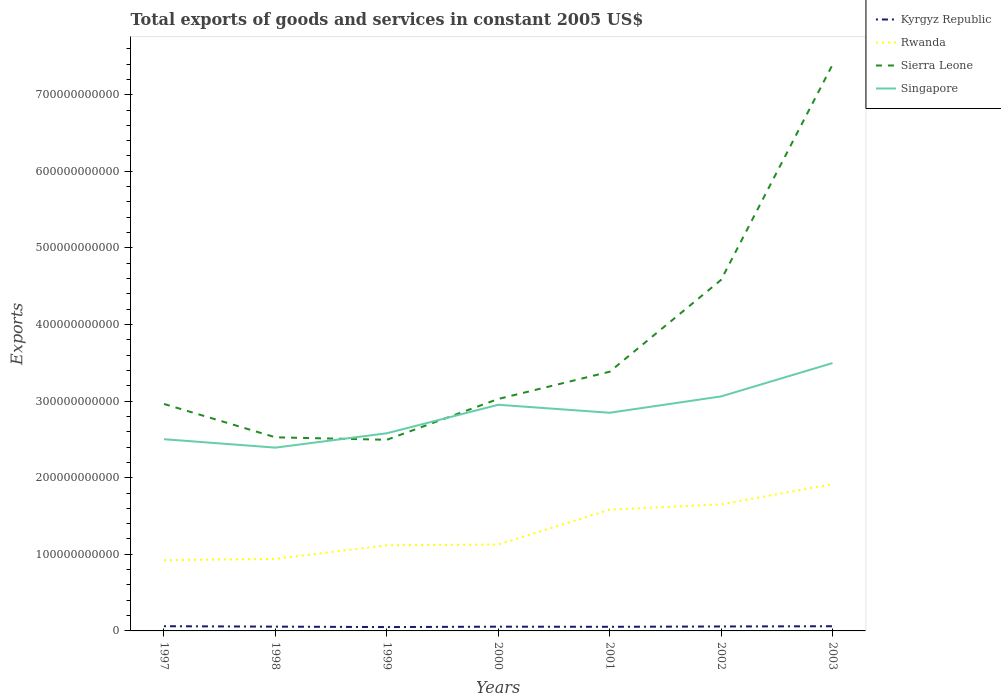How many different coloured lines are there?
Your answer should be very brief. 4. Is the number of lines equal to the number of legend labels?
Provide a short and direct response. Yes. Across all years, what is the maximum total exports of goods and services in Rwanda?
Provide a short and direct response. 9.23e+1. What is the total total exports of goods and services in Sierra Leone in the graph?
Offer a very short reply. -6.50e+09. What is the difference between the highest and the second highest total exports of goods and services in Singapore?
Offer a terse response. 1.10e+11. What is the difference between the highest and the lowest total exports of goods and services in Sierra Leone?
Ensure brevity in your answer.  2. How many years are there in the graph?
Provide a succinct answer. 7. What is the difference between two consecutive major ticks on the Y-axis?
Give a very brief answer. 1.00e+11. Does the graph contain any zero values?
Make the answer very short. No. What is the title of the graph?
Your response must be concise. Total exports of goods and services in constant 2005 US$. What is the label or title of the X-axis?
Make the answer very short. Years. What is the label or title of the Y-axis?
Ensure brevity in your answer.  Exports. What is the Exports in Kyrgyz Republic in 1997?
Keep it short and to the point. 6.14e+09. What is the Exports in Rwanda in 1997?
Provide a short and direct response. 9.23e+1. What is the Exports in Sierra Leone in 1997?
Give a very brief answer. 2.96e+11. What is the Exports of Singapore in 1997?
Your answer should be very brief. 2.50e+11. What is the Exports in Kyrgyz Republic in 1998?
Your response must be concise. 5.61e+09. What is the Exports in Rwanda in 1998?
Keep it short and to the point. 9.41e+1. What is the Exports of Sierra Leone in 1998?
Make the answer very short. 2.53e+11. What is the Exports in Singapore in 1998?
Make the answer very short. 2.39e+11. What is the Exports in Kyrgyz Republic in 1999?
Ensure brevity in your answer.  5.02e+09. What is the Exports in Rwanda in 1999?
Give a very brief answer. 1.12e+11. What is the Exports of Sierra Leone in 1999?
Your response must be concise. 2.50e+11. What is the Exports in Singapore in 1999?
Your answer should be very brief. 2.58e+11. What is the Exports of Kyrgyz Republic in 2000?
Provide a succinct answer. 5.55e+09. What is the Exports in Rwanda in 2000?
Provide a short and direct response. 1.13e+11. What is the Exports in Sierra Leone in 2000?
Provide a short and direct response. 3.03e+11. What is the Exports in Singapore in 2000?
Offer a terse response. 2.95e+11. What is the Exports of Kyrgyz Republic in 2001?
Give a very brief answer. 5.37e+09. What is the Exports of Rwanda in 2001?
Keep it short and to the point. 1.58e+11. What is the Exports in Sierra Leone in 2001?
Make the answer very short. 3.38e+11. What is the Exports of Singapore in 2001?
Provide a succinct answer. 2.85e+11. What is the Exports of Kyrgyz Republic in 2002?
Offer a terse response. 5.81e+09. What is the Exports in Rwanda in 2002?
Keep it short and to the point. 1.65e+11. What is the Exports of Sierra Leone in 2002?
Offer a terse response. 4.58e+11. What is the Exports in Singapore in 2002?
Provide a short and direct response. 3.06e+11. What is the Exports of Kyrgyz Republic in 2003?
Keep it short and to the point. 6.11e+09. What is the Exports in Rwanda in 2003?
Your answer should be compact. 1.92e+11. What is the Exports of Sierra Leone in 2003?
Offer a very short reply. 7.39e+11. What is the Exports of Singapore in 2003?
Give a very brief answer. 3.50e+11. Across all years, what is the maximum Exports of Kyrgyz Republic?
Provide a succinct answer. 6.14e+09. Across all years, what is the maximum Exports of Rwanda?
Provide a succinct answer. 1.92e+11. Across all years, what is the maximum Exports of Sierra Leone?
Ensure brevity in your answer.  7.39e+11. Across all years, what is the maximum Exports of Singapore?
Your answer should be very brief. 3.50e+11. Across all years, what is the minimum Exports in Kyrgyz Republic?
Your response must be concise. 5.02e+09. Across all years, what is the minimum Exports in Rwanda?
Offer a terse response. 9.23e+1. Across all years, what is the minimum Exports of Sierra Leone?
Make the answer very short. 2.50e+11. Across all years, what is the minimum Exports of Singapore?
Ensure brevity in your answer.  2.39e+11. What is the total Exports in Kyrgyz Republic in the graph?
Provide a succinct answer. 3.96e+1. What is the total Exports of Rwanda in the graph?
Ensure brevity in your answer.  9.26e+11. What is the total Exports in Sierra Leone in the graph?
Provide a succinct answer. 2.64e+12. What is the total Exports in Singapore in the graph?
Your answer should be compact. 1.98e+12. What is the difference between the Exports of Kyrgyz Republic in 1997 and that in 1998?
Give a very brief answer. 5.37e+08. What is the difference between the Exports of Rwanda in 1997 and that in 1998?
Ensure brevity in your answer.  -1.75e+09. What is the difference between the Exports in Sierra Leone in 1997 and that in 1998?
Ensure brevity in your answer.  4.36e+1. What is the difference between the Exports of Singapore in 1997 and that in 1998?
Provide a short and direct response. 1.10e+1. What is the difference between the Exports in Kyrgyz Republic in 1997 and that in 1999?
Offer a terse response. 1.12e+09. What is the difference between the Exports of Rwanda in 1997 and that in 1999?
Your answer should be compact. -1.95e+1. What is the difference between the Exports in Sierra Leone in 1997 and that in 1999?
Provide a succinct answer. 4.68e+1. What is the difference between the Exports of Singapore in 1997 and that in 1999?
Make the answer very short. -7.75e+09. What is the difference between the Exports in Kyrgyz Republic in 1997 and that in 2000?
Provide a succinct answer. 5.92e+08. What is the difference between the Exports in Rwanda in 1997 and that in 2000?
Give a very brief answer. -2.05e+1. What is the difference between the Exports in Sierra Leone in 1997 and that in 2000?
Offer a very short reply. -6.50e+09. What is the difference between the Exports in Singapore in 1997 and that in 2000?
Give a very brief answer. -4.50e+1. What is the difference between the Exports in Kyrgyz Republic in 1997 and that in 2001?
Provide a short and direct response. 7.72e+08. What is the difference between the Exports of Rwanda in 1997 and that in 2001?
Your answer should be compact. -6.59e+1. What is the difference between the Exports of Sierra Leone in 1997 and that in 2001?
Your answer should be very brief. -4.21e+1. What is the difference between the Exports in Singapore in 1997 and that in 2001?
Give a very brief answer. -3.45e+1. What is the difference between the Exports of Kyrgyz Republic in 1997 and that in 2002?
Ensure brevity in your answer.  3.38e+08. What is the difference between the Exports in Rwanda in 1997 and that in 2002?
Provide a short and direct response. -7.29e+1. What is the difference between the Exports of Sierra Leone in 1997 and that in 2002?
Your answer should be very brief. -1.62e+11. What is the difference between the Exports of Singapore in 1997 and that in 2002?
Your response must be concise. -5.59e+1. What is the difference between the Exports in Kyrgyz Republic in 1997 and that in 2003?
Your answer should be compact. 3.05e+07. What is the difference between the Exports in Rwanda in 1997 and that in 2003?
Offer a very short reply. -9.93e+1. What is the difference between the Exports in Sierra Leone in 1997 and that in 2003?
Offer a very short reply. -4.43e+11. What is the difference between the Exports in Singapore in 1997 and that in 2003?
Your answer should be very brief. -9.94e+1. What is the difference between the Exports in Kyrgyz Republic in 1998 and that in 1999?
Provide a succinct answer. 5.83e+08. What is the difference between the Exports of Rwanda in 1998 and that in 1999?
Make the answer very short. -1.77e+1. What is the difference between the Exports of Sierra Leone in 1998 and that in 1999?
Provide a succinct answer. 3.23e+09. What is the difference between the Exports in Singapore in 1998 and that in 1999?
Your answer should be compact. -1.87e+1. What is the difference between the Exports in Kyrgyz Republic in 1998 and that in 2000?
Make the answer very short. 5.52e+07. What is the difference between the Exports in Rwanda in 1998 and that in 2000?
Give a very brief answer. -1.87e+1. What is the difference between the Exports of Sierra Leone in 1998 and that in 2000?
Keep it short and to the point. -5.01e+1. What is the difference between the Exports in Singapore in 1998 and that in 2000?
Ensure brevity in your answer.  -5.60e+1. What is the difference between the Exports in Kyrgyz Republic in 1998 and that in 2001?
Make the answer very short. 2.35e+08. What is the difference between the Exports in Rwanda in 1998 and that in 2001?
Offer a very short reply. -6.41e+1. What is the difference between the Exports in Sierra Leone in 1998 and that in 2001?
Keep it short and to the point. -8.56e+1. What is the difference between the Exports of Singapore in 1998 and that in 2001?
Keep it short and to the point. -4.55e+1. What is the difference between the Exports of Kyrgyz Republic in 1998 and that in 2002?
Your answer should be compact. -1.99e+08. What is the difference between the Exports of Rwanda in 1998 and that in 2002?
Ensure brevity in your answer.  -7.12e+1. What is the difference between the Exports of Sierra Leone in 1998 and that in 2002?
Offer a very short reply. -2.06e+11. What is the difference between the Exports in Singapore in 1998 and that in 2002?
Make the answer very short. -6.69e+1. What is the difference between the Exports in Kyrgyz Republic in 1998 and that in 2003?
Your answer should be compact. -5.06e+08. What is the difference between the Exports in Rwanda in 1998 and that in 2003?
Provide a succinct answer. -9.76e+1. What is the difference between the Exports in Sierra Leone in 1998 and that in 2003?
Provide a short and direct response. -4.86e+11. What is the difference between the Exports of Singapore in 1998 and that in 2003?
Provide a succinct answer. -1.10e+11. What is the difference between the Exports in Kyrgyz Republic in 1999 and that in 2000?
Keep it short and to the point. -5.28e+08. What is the difference between the Exports of Rwanda in 1999 and that in 2000?
Ensure brevity in your answer.  -9.73e+08. What is the difference between the Exports in Sierra Leone in 1999 and that in 2000?
Your response must be concise. -5.33e+1. What is the difference between the Exports of Singapore in 1999 and that in 2000?
Make the answer very short. -3.72e+1. What is the difference between the Exports of Kyrgyz Republic in 1999 and that in 2001?
Give a very brief answer. -3.48e+08. What is the difference between the Exports of Rwanda in 1999 and that in 2001?
Your response must be concise. -4.64e+1. What is the difference between the Exports of Sierra Leone in 1999 and that in 2001?
Make the answer very short. -8.89e+1. What is the difference between the Exports in Singapore in 1999 and that in 2001?
Keep it short and to the point. -2.68e+1. What is the difference between the Exports in Kyrgyz Republic in 1999 and that in 2002?
Offer a very short reply. -7.82e+08. What is the difference between the Exports in Rwanda in 1999 and that in 2002?
Provide a succinct answer. -5.34e+1. What is the difference between the Exports of Sierra Leone in 1999 and that in 2002?
Your answer should be very brief. -2.09e+11. What is the difference between the Exports of Singapore in 1999 and that in 2002?
Your answer should be compact. -4.81e+1. What is the difference between the Exports of Kyrgyz Republic in 1999 and that in 2003?
Provide a succinct answer. -1.09e+09. What is the difference between the Exports in Rwanda in 1999 and that in 2003?
Keep it short and to the point. -7.98e+1. What is the difference between the Exports of Sierra Leone in 1999 and that in 2003?
Offer a terse response. -4.90e+11. What is the difference between the Exports of Singapore in 1999 and that in 2003?
Your answer should be compact. -9.16e+1. What is the difference between the Exports of Kyrgyz Republic in 2000 and that in 2001?
Offer a terse response. 1.80e+08. What is the difference between the Exports in Rwanda in 2000 and that in 2001?
Provide a succinct answer. -4.54e+1. What is the difference between the Exports of Sierra Leone in 2000 and that in 2001?
Your answer should be compact. -3.56e+1. What is the difference between the Exports of Singapore in 2000 and that in 2001?
Offer a terse response. 1.04e+1. What is the difference between the Exports of Kyrgyz Republic in 2000 and that in 2002?
Make the answer very short. -2.54e+08. What is the difference between the Exports of Rwanda in 2000 and that in 2002?
Keep it short and to the point. -5.25e+1. What is the difference between the Exports of Sierra Leone in 2000 and that in 2002?
Provide a succinct answer. -1.55e+11. What is the difference between the Exports of Singapore in 2000 and that in 2002?
Your answer should be very brief. -1.09e+1. What is the difference between the Exports in Kyrgyz Republic in 2000 and that in 2003?
Your answer should be very brief. -5.61e+08. What is the difference between the Exports in Rwanda in 2000 and that in 2003?
Ensure brevity in your answer.  -7.88e+1. What is the difference between the Exports in Sierra Leone in 2000 and that in 2003?
Your response must be concise. -4.36e+11. What is the difference between the Exports of Singapore in 2000 and that in 2003?
Offer a very short reply. -5.44e+1. What is the difference between the Exports of Kyrgyz Republic in 2001 and that in 2002?
Your response must be concise. -4.34e+08. What is the difference between the Exports in Rwanda in 2001 and that in 2002?
Provide a succinct answer. -7.03e+09. What is the difference between the Exports in Sierra Leone in 2001 and that in 2002?
Offer a terse response. -1.20e+11. What is the difference between the Exports of Singapore in 2001 and that in 2002?
Give a very brief answer. -2.13e+1. What is the difference between the Exports of Kyrgyz Republic in 2001 and that in 2003?
Ensure brevity in your answer.  -7.41e+08. What is the difference between the Exports in Rwanda in 2001 and that in 2003?
Offer a terse response. -3.34e+1. What is the difference between the Exports of Sierra Leone in 2001 and that in 2003?
Your answer should be very brief. -4.01e+11. What is the difference between the Exports of Singapore in 2001 and that in 2003?
Offer a terse response. -6.49e+1. What is the difference between the Exports of Kyrgyz Republic in 2002 and that in 2003?
Make the answer very short. -3.07e+08. What is the difference between the Exports of Rwanda in 2002 and that in 2003?
Your response must be concise. -2.64e+1. What is the difference between the Exports of Sierra Leone in 2002 and that in 2003?
Offer a terse response. -2.81e+11. What is the difference between the Exports in Singapore in 2002 and that in 2003?
Make the answer very short. -4.35e+1. What is the difference between the Exports of Kyrgyz Republic in 1997 and the Exports of Rwanda in 1998?
Make the answer very short. -8.79e+1. What is the difference between the Exports of Kyrgyz Republic in 1997 and the Exports of Sierra Leone in 1998?
Make the answer very short. -2.47e+11. What is the difference between the Exports of Kyrgyz Republic in 1997 and the Exports of Singapore in 1998?
Your answer should be very brief. -2.33e+11. What is the difference between the Exports in Rwanda in 1997 and the Exports in Sierra Leone in 1998?
Keep it short and to the point. -1.60e+11. What is the difference between the Exports of Rwanda in 1997 and the Exports of Singapore in 1998?
Your answer should be compact. -1.47e+11. What is the difference between the Exports of Sierra Leone in 1997 and the Exports of Singapore in 1998?
Provide a succinct answer. 5.70e+1. What is the difference between the Exports of Kyrgyz Republic in 1997 and the Exports of Rwanda in 1999?
Provide a succinct answer. -1.06e+11. What is the difference between the Exports of Kyrgyz Republic in 1997 and the Exports of Sierra Leone in 1999?
Your response must be concise. -2.43e+11. What is the difference between the Exports of Kyrgyz Republic in 1997 and the Exports of Singapore in 1999?
Your response must be concise. -2.52e+11. What is the difference between the Exports of Rwanda in 1997 and the Exports of Sierra Leone in 1999?
Offer a terse response. -1.57e+11. What is the difference between the Exports of Rwanda in 1997 and the Exports of Singapore in 1999?
Offer a very short reply. -1.66e+11. What is the difference between the Exports in Sierra Leone in 1997 and the Exports in Singapore in 1999?
Provide a short and direct response. 3.83e+1. What is the difference between the Exports in Kyrgyz Republic in 1997 and the Exports in Rwanda in 2000?
Ensure brevity in your answer.  -1.07e+11. What is the difference between the Exports of Kyrgyz Republic in 1997 and the Exports of Sierra Leone in 2000?
Your answer should be very brief. -2.97e+11. What is the difference between the Exports in Kyrgyz Republic in 1997 and the Exports in Singapore in 2000?
Your response must be concise. -2.89e+11. What is the difference between the Exports in Rwanda in 1997 and the Exports in Sierra Leone in 2000?
Give a very brief answer. -2.10e+11. What is the difference between the Exports of Rwanda in 1997 and the Exports of Singapore in 2000?
Offer a very short reply. -2.03e+11. What is the difference between the Exports in Sierra Leone in 1997 and the Exports in Singapore in 2000?
Ensure brevity in your answer.  1.06e+09. What is the difference between the Exports in Kyrgyz Republic in 1997 and the Exports in Rwanda in 2001?
Your answer should be compact. -1.52e+11. What is the difference between the Exports of Kyrgyz Republic in 1997 and the Exports of Sierra Leone in 2001?
Provide a succinct answer. -3.32e+11. What is the difference between the Exports in Kyrgyz Republic in 1997 and the Exports in Singapore in 2001?
Keep it short and to the point. -2.79e+11. What is the difference between the Exports in Rwanda in 1997 and the Exports in Sierra Leone in 2001?
Give a very brief answer. -2.46e+11. What is the difference between the Exports of Rwanda in 1997 and the Exports of Singapore in 2001?
Keep it short and to the point. -1.92e+11. What is the difference between the Exports in Sierra Leone in 1997 and the Exports in Singapore in 2001?
Provide a short and direct response. 1.15e+1. What is the difference between the Exports in Kyrgyz Republic in 1997 and the Exports in Rwanda in 2002?
Keep it short and to the point. -1.59e+11. What is the difference between the Exports in Kyrgyz Republic in 1997 and the Exports in Sierra Leone in 2002?
Give a very brief answer. -4.52e+11. What is the difference between the Exports in Kyrgyz Republic in 1997 and the Exports in Singapore in 2002?
Offer a very short reply. -3.00e+11. What is the difference between the Exports in Rwanda in 1997 and the Exports in Sierra Leone in 2002?
Keep it short and to the point. -3.66e+11. What is the difference between the Exports in Rwanda in 1997 and the Exports in Singapore in 2002?
Make the answer very short. -2.14e+11. What is the difference between the Exports in Sierra Leone in 1997 and the Exports in Singapore in 2002?
Give a very brief answer. -9.84e+09. What is the difference between the Exports in Kyrgyz Republic in 1997 and the Exports in Rwanda in 2003?
Provide a succinct answer. -1.85e+11. What is the difference between the Exports of Kyrgyz Republic in 1997 and the Exports of Sierra Leone in 2003?
Provide a succinct answer. -7.33e+11. What is the difference between the Exports of Kyrgyz Republic in 1997 and the Exports of Singapore in 2003?
Ensure brevity in your answer.  -3.44e+11. What is the difference between the Exports in Rwanda in 1997 and the Exports in Sierra Leone in 2003?
Your response must be concise. -6.47e+11. What is the difference between the Exports of Rwanda in 1997 and the Exports of Singapore in 2003?
Ensure brevity in your answer.  -2.57e+11. What is the difference between the Exports in Sierra Leone in 1997 and the Exports in Singapore in 2003?
Give a very brief answer. -5.33e+1. What is the difference between the Exports of Kyrgyz Republic in 1998 and the Exports of Rwanda in 1999?
Your answer should be very brief. -1.06e+11. What is the difference between the Exports in Kyrgyz Republic in 1998 and the Exports in Sierra Leone in 1999?
Your response must be concise. -2.44e+11. What is the difference between the Exports in Kyrgyz Republic in 1998 and the Exports in Singapore in 1999?
Provide a succinct answer. -2.52e+11. What is the difference between the Exports in Rwanda in 1998 and the Exports in Sierra Leone in 1999?
Make the answer very short. -1.55e+11. What is the difference between the Exports of Rwanda in 1998 and the Exports of Singapore in 1999?
Offer a very short reply. -1.64e+11. What is the difference between the Exports in Sierra Leone in 1998 and the Exports in Singapore in 1999?
Your answer should be compact. -5.26e+09. What is the difference between the Exports of Kyrgyz Republic in 1998 and the Exports of Rwanda in 2000?
Give a very brief answer. -1.07e+11. What is the difference between the Exports of Kyrgyz Republic in 1998 and the Exports of Sierra Leone in 2000?
Make the answer very short. -2.97e+11. What is the difference between the Exports of Kyrgyz Republic in 1998 and the Exports of Singapore in 2000?
Offer a very short reply. -2.90e+11. What is the difference between the Exports in Rwanda in 1998 and the Exports in Sierra Leone in 2000?
Your response must be concise. -2.09e+11. What is the difference between the Exports of Rwanda in 1998 and the Exports of Singapore in 2000?
Provide a short and direct response. -2.01e+11. What is the difference between the Exports in Sierra Leone in 1998 and the Exports in Singapore in 2000?
Keep it short and to the point. -4.25e+1. What is the difference between the Exports of Kyrgyz Republic in 1998 and the Exports of Rwanda in 2001?
Provide a short and direct response. -1.53e+11. What is the difference between the Exports in Kyrgyz Republic in 1998 and the Exports in Sierra Leone in 2001?
Your response must be concise. -3.33e+11. What is the difference between the Exports of Kyrgyz Republic in 1998 and the Exports of Singapore in 2001?
Give a very brief answer. -2.79e+11. What is the difference between the Exports of Rwanda in 1998 and the Exports of Sierra Leone in 2001?
Your response must be concise. -2.44e+11. What is the difference between the Exports in Rwanda in 1998 and the Exports in Singapore in 2001?
Offer a terse response. -1.91e+11. What is the difference between the Exports in Sierra Leone in 1998 and the Exports in Singapore in 2001?
Offer a very short reply. -3.20e+1. What is the difference between the Exports of Kyrgyz Republic in 1998 and the Exports of Rwanda in 2002?
Your answer should be very brief. -1.60e+11. What is the difference between the Exports in Kyrgyz Republic in 1998 and the Exports in Sierra Leone in 2002?
Keep it short and to the point. -4.53e+11. What is the difference between the Exports in Kyrgyz Republic in 1998 and the Exports in Singapore in 2002?
Your answer should be compact. -3.01e+11. What is the difference between the Exports of Rwanda in 1998 and the Exports of Sierra Leone in 2002?
Make the answer very short. -3.64e+11. What is the difference between the Exports in Rwanda in 1998 and the Exports in Singapore in 2002?
Provide a short and direct response. -2.12e+11. What is the difference between the Exports in Sierra Leone in 1998 and the Exports in Singapore in 2002?
Offer a terse response. -5.34e+1. What is the difference between the Exports of Kyrgyz Republic in 1998 and the Exports of Rwanda in 2003?
Your answer should be compact. -1.86e+11. What is the difference between the Exports in Kyrgyz Republic in 1998 and the Exports in Sierra Leone in 2003?
Your answer should be very brief. -7.34e+11. What is the difference between the Exports of Kyrgyz Republic in 1998 and the Exports of Singapore in 2003?
Offer a very short reply. -3.44e+11. What is the difference between the Exports in Rwanda in 1998 and the Exports in Sierra Leone in 2003?
Keep it short and to the point. -6.45e+11. What is the difference between the Exports in Rwanda in 1998 and the Exports in Singapore in 2003?
Provide a succinct answer. -2.56e+11. What is the difference between the Exports of Sierra Leone in 1998 and the Exports of Singapore in 2003?
Offer a very short reply. -9.69e+1. What is the difference between the Exports in Kyrgyz Republic in 1999 and the Exports in Rwanda in 2000?
Offer a terse response. -1.08e+11. What is the difference between the Exports in Kyrgyz Republic in 1999 and the Exports in Sierra Leone in 2000?
Offer a very short reply. -2.98e+11. What is the difference between the Exports of Kyrgyz Republic in 1999 and the Exports of Singapore in 2000?
Your answer should be very brief. -2.90e+11. What is the difference between the Exports of Rwanda in 1999 and the Exports of Sierra Leone in 2000?
Offer a terse response. -1.91e+11. What is the difference between the Exports of Rwanda in 1999 and the Exports of Singapore in 2000?
Provide a succinct answer. -1.83e+11. What is the difference between the Exports of Sierra Leone in 1999 and the Exports of Singapore in 2000?
Your answer should be compact. -4.57e+1. What is the difference between the Exports in Kyrgyz Republic in 1999 and the Exports in Rwanda in 2001?
Your answer should be compact. -1.53e+11. What is the difference between the Exports of Kyrgyz Republic in 1999 and the Exports of Sierra Leone in 2001?
Ensure brevity in your answer.  -3.33e+11. What is the difference between the Exports in Kyrgyz Republic in 1999 and the Exports in Singapore in 2001?
Your answer should be very brief. -2.80e+11. What is the difference between the Exports of Rwanda in 1999 and the Exports of Sierra Leone in 2001?
Offer a terse response. -2.27e+11. What is the difference between the Exports of Rwanda in 1999 and the Exports of Singapore in 2001?
Provide a short and direct response. -1.73e+11. What is the difference between the Exports of Sierra Leone in 1999 and the Exports of Singapore in 2001?
Your response must be concise. -3.53e+1. What is the difference between the Exports of Kyrgyz Republic in 1999 and the Exports of Rwanda in 2002?
Provide a short and direct response. -1.60e+11. What is the difference between the Exports of Kyrgyz Republic in 1999 and the Exports of Sierra Leone in 2002?
Your answer should be compact. -4.53e+11. What is the difference between the Exports of Kyrgyz Republic in 1999 and the Exports of Singapore in 2002?
Give a very brief answer. -3.01e+11. What is the difference between the Exports in Rwanda in 1999 and the Exports in Sierra Leone in 2002?
Offer a terse response. -3.46e+11. What is the difference between the Exports of Rwanda in 1999 and the Exports of Singapore in 2002?
Make the answer very short. -1.94e+11. What is the difference between the Exports in Sierra Leone in 1999 and the Exports in Singapore in 2002?
Ensure brevity in your answer.  -5.66e+1. What is the difference between the Exports of Kyrgyz Republic in 1999 and the Exports of Rwanda in 2003?
Your response must be concise. -1.87e+11. What is the difference between the Exports in Kyrgyz Republic in 1999 and the Exports in Sierra Leone in 2003?
Your answer should be compact. -7.34e+11. What is the difference between the Exports of Kyrgyz Republic in 1999 and the Exports of Singapore in 2003?
Give a very brief answer. -3.45e+11. What is the difference between the Exports in Rwanda in 1999 and the Exports in Sierra Leone in 2003?
Give a very brief answer. -6.27e+11. What is the difference between the Exports in Rwanda in 1999 and the Exports in Singapore in 2003?
Your answer should be compact. -2.38e+11. What is the difference between the Exports of Sierra Leone in 1999 and the Exports of Singapore in 2003?
Provide a short and direct response. -1.00e+11. What is the difference between the Exports in Kyrgyz Republic in 2000 and the Exports in Rwanda in 2001?
Your answer should be compact. -1.53e+11. What is the difference between the Exports in Kyrgyz Republic in 2000 and the Exports in Sierra Leone in 2001?
Your answer should be very brief. -3.33e+11. What is the difference between the Exports of Kyrgyz Republic in 2000 and the Exports of Singapore in 2001?
Your answer should be compact. -2.79e+11. What is the difference between the Exports in Rwanda in 2000 and the Exports in Sierra Leone in 2001?
Your response must be concise. -2.26e+11. What is the difference between the Exports of Rwanda in 2000 and the Exports of Singapore in 2001?
Your answer should be compact. -1.72e+11. What is the difference between the Exports of Sierra Leone in 2000 and the Exports of Singapore in 2001?
Provide a succinct answer. 1.80e+1. What is the difference between the Exports of Kyrgyz Republic in 2000 and the Exports of Rwanda in 2002?
Your response must be concise. -1.60e+11. What is the difference between the Exports in Kyrgyz Republic in 2000 and the Exports in Sierra Leone in 2002?
Give a very brief answer. -4.53e+11. What is the difference between the Exports in Kyrgyz Republic in 2000 and the Exports in Singapore in 2002?
Make the answer very short. -3.01e+11. What is the difference between the Exports of Rwanda in 2000 and the Exports of Sierra Leone in 2002?
Provide a short and direct response. -3.46e+11. What is the difference between the Exports in Rwanda in 2000 and the Exports in Singapore in 2002?
Keep it short and to the point. -1.93e+11. What is the difference between the Exports of Sierra Leone in 2000 and the Exports of Singapore in 2002?
Keep it short and to the point. -3.34e+09. What is the difference between the Exports in Kyrgyz Republic in 2000 and the Exports in Rwanda in 2003?
Provide a short and direct response. -1.86e+11. What is the difference between the Exports in Kyrgyz Republic in 2000 and the Exports in Sierra Leone in 2003?
Your response must be concise. -7.34e+11. What is the difference between the Exports of Kyrgyz Republic in 2000 and the Exports of Singapore in 2003?
Your answer should be compact. -3.44e+11. What is the difference between the Exports in Rwanda in 2000 and the Exports in Sierra Leone in 2003?
Your answer should be compact. -6.26e+11. What is the difference between the Exports of Rwanda in 2000 and the Exports of Singapore in 2003?
Provide a short and direct response. -2.37e+11. What is the difference between the Exports of Sierra Leone in 2000 and the Exports of Singapore in 2003?
Give a very brief answer. -4.68e+1. What is the difference between the Exports in Kyrgyz Republic in 2001 and the Exports in Rwanda in 2002?
Your answer should be compact. -1.60e+11. What is the difference between the Exports in Kyrgyz Republic in 2001 and the Exports in Sierra Leone in 2002?
Your answer should be compact. -4.53e+11. What is the difference between the Exports in Kyrgyz Republic in 2001 and the Exports in Singapore in 2002?
Ensure brevity in your answer.  -3.01e+11. What is the difference between the Exports in Rwanda in 2001 and the Exports in Sierra Leone in 2002?
Your response must be concise. -3.00e+11. What is the difference between the Exports in Rwanda in 2001 and the Exports in Singapore in 2002?
Your answer should be very brief. -1.48e+11. What is the difference between the Exports of Sierra Leone in 2001 and the Exports of Singapore in 2002?
Provide a succinct answer. 3.22e+1. What is the difference between the Exports of Kyrgyz Republic in 2001 and the Exports of Rwanda in 2003?
Your answer should be compact. -1.86e+11. What is the difference between the Exports in Kyrgyz Republic in 2001 and the Exports in Sierra Leone in 2003?
Keep it short and to the point. -7.34e+11. What is the difference between the Exports in Kyrgyz Republic in 2001 and the Exports in Singapore in 2003?
Your answer should be very brief. -3.44e+11. What is the difference between the Exports in Rwanda in 2001 and the Exports in Sierra Leone in 2003?
Provide a succinct answer. -5.81e+11. What is the difference between the Exports of Rwanda in 2001 and the Exports of Singapore in 2003?
Keep it short and to the point. -1.91e+11. What is the difference between the Exports in Sierra Leone in 2001 and the Exports in Singapore in 2003?
Your answer should be very brief. -1.13e+1. What is the difference between the Exports in Kyrgyz Republic in 2002 and the Exports in Rwanda in 2003?
Offer a terse response. -1.86e+11. What is the difference between the Exports of Kyrgyz Republic in 2002 and the Exports of Sierra Leone in 2003?
Give a very brief answer. -7.33e+11. What is the difference between the Exports of Kyrgyz Republic in 2002 and the Exports of Singapore in 2003?
Provide a short and direct response. -3.44e+11. What is the difference between the Exports of Rwanda in 2002 and the Exports of Sierra Leone in 2003?
Offer a terse response. -5.74e+11. What is the difference between the Exports in Rwanda in 2002 and the Exports in Singapore in 2003?
Provide a succinct answer. -1.84e+11. What is the difference between the Exports of Sierra Leone in 2002 and the Exports of Singapore in 2003?
Make the answer very short. 1.09e+11. What is the average Exports of Kyrgyz Republic per year?
Offer a terse response. 5.66e+09. What is the average Exports in Rwanda per year?
Ensure brevity in your answer.  1.32e+11. What is the average Exports of Sierra Leone per year?
Make the answer very short. 3.77e+11. What is the average Exports in Singapore per year?
Your answer should be compact. 2.83e+11. In the year 1997, what is the difference between the Exports in Kyrgyz Republic and Exports in Rwanda?
Your answer should be very brief. -8.62e+1. In the year 1997, what is the difference between the Exports in Kyrgyz Republic and Exports in Sierra Leone?
Make the answer very short. -2.90e+11. In the year 1997, what is the difference between the Exports in Kyrgyz Republic and Exports in Singapore?
Provide a succinct answer. -2.44e+11. In the year 1997, what is the difference between the Exports of Rwanda and Exports of Sierra Leone?
Your response must be concise. -2.04e+11. In the year 1997, what is the difference between the Exports in Rwanda and Exports in Singapore?
Keep it short and to the point. -1.58e+11. In the year 1997, what is the difference between the Exports in Sierra Leone and Exports in Singapore?
Your answer should be very brief. 4.60e+1. In the year 1998, what is the difference between the Exports in Kyrgyz Republic and Exports in Rwanda?
Give a very brief answer. -8.85e+1. In the year 1998, what is the difference between the Exports of Kyrgyz Republic and Exports of Sierra Leone?
Make the answer very short. -2.47e+11. In the year 1998, what is the difference between the Exports of Kyrgyz Republic and Exports of Singapore?
Ensure brevity in your answer.  -2.34e+11. In the year 1998, what is the difference between the Exports in Rwanda and Exports in Sierra Leone?
Offer a terse response. -1.59e+11. In the year 1998, what is the difference between the Exports of Rwanda and Exports of Singapore?
Make the answer very short. -1.45e+11. In the year 1998, what is the difference between the Exports in Sierra Leone and Exports in Singapore?
Offer a very short reply. 1.35e+1. In the year 1999, what is the difference between the Exports of Kyrgyz Republic and Exports of Rwanda?
Your answer should be compact. -1.07e+11. In the year 1999, what is the difference between the Exports in Kyrgyz Republic and Exports in Sierra Leone?
Your answer should be compact. -2.44e+11. In the year 1999, what is the difference between the Exports in Kyrgyz Republic and Exports in Singapore?
Provide a short and direct response. -2.53e+11. In the year 1999, what is the difference between the Exports in Rwanda and Exports in Sierra Leone?
Give a very brief answer. -1.38e+11. In the year 1999, what is the difference between the Exports of Rwanda and Exports of Singapore?
Provide a short and direct response. -1.46e+11. In the year 1999, what is the difference between the Exports of Sierra Leone and Exports of Singapore?
Keep it short and to the point. -8.49e+09. In the year 2000, what is the difference between the Exports of Kyrgyz Republic and Exports of Rwanda?
Your response must be concise. -1.07e+11. In the year 2000, what is the difference between the Exports in Kyrgyz Republic and Exports in Sierra Leone?
Give a very brief answer. -2.97e+11. In the year 2000, what is the difference between the Exports of Kyrgyz Republic and Exports of Singapore?
Offer a terse response. -2.90e+11. In the year 2000, what is the difference between the Exports of Rwanda and Exports of Sierra Leone?
Your answer should be compact. -1.90e+11. In the year 2000, what is the difference between the Exports of Rwanda and Exports of Singapore?
Your response must be concise. -1.82e+11. In the year 2000, what is the difference between the Exports of Sierra Leone and Exports of Singapore?
Offer a terse response. 7.56e+09. In the year 2001, what is the difference between the Exports of Kyrgyz Republic and Exports of Rwanda?
Your answer should be compact. -1.53e+11. In the year 2001, what is the difference between the Exports in Kyrgyz Republic and Exports in Sierra Leone?
Offer a terse response. -3.33e+11. In the year 2001, what is the difference between the Exports of Kyrgyz Republic and Exports of Singapore?
Your response must be concise. -2.79e+11. In the year 2001, what is the difference between the Exports of Rwanda and Exports of Sierra Leone?
Your answer should be very brief. -1.80e+11. In the year 2001, what is the difference between the Exports of Rwanda and Exports of Singapore?
Your answer should be compact. -1.27e+11. In the year 2001, what is the difference between the Exports of Sierra Leone and Exports of Singapore?
Offer a very short reply. 5.36e+1. In the year 2002, what is the difference between the Exports in Kyrgyz Republic and Exports in Rwanda?
Provide a short and direct response. -1.59e+11. In the year 2002, what is the difference between the Exports of Kyrgyz Republic and Exports of Sierra Leone?
Ensure brevity in your answer.  -4.52e+11. In the year 2002, what is the difference between the Exports of Kyrgyz Republic and Exports of Singapore?
Offer a terse response. -3.00e+11. In the year 2002, what is the difference between the Exports in Rwanda and Exports in Sierra Leone?
Provide a short and direct response. -2.93e+11. In the year 2002, what is the difference between the Exports in Rwanda and Exports in Singapore?
Offer a terse response. -1.41e+11. In the year 2002, what is the difference between the Exports of Sierra Leone and Exports of Singapore?
Keep it short and to the point. 1.52e+11. In the year 2003, what is the difference between the Exports in Kyrgyz Republic and Exports in Rwanda?
Offer a terse response. -1.86e+11. In the year 2003, what is the difference between the Exports in Kyrgyz Republic and Exports in Sierra Leone?
Offer a very short reply. -7.33e+11. In the year 2003, what is the difference between the Exports in Kyrgyz Republic and Exports in Singapore?
Make the answer very short. -3.44e+11. In the year 2003, what is the difference between the Exports in Rwanda and Exports in Sierra Leone?
Your answer should be compact. -5.48e+11. In the year 2003, what is the difference between the Exports of Rwanda and Exports of Singapore?
Your response must be concise. -1.58e+11. In the year 2003, what is the difference between the Exports of Sierra Leone and Exports of Singapore?
Keep it short and to the point. 3.90e+11. What is the ratio of the Exports in Kyrgyz Republic in 1997 to that in 1998?
Offer a very short reply. 1.1. What is the ratio of the Exports of Rwanda in 1997 to that in 1998?
Offer a terse response. 0.98. What is the ratio of the Exports in Sierra Leone in 1997 to that in 1998?
Offer a terse response. 1.17. What is the ratio of the Exports of Singapore in 1997 to that in 1998?
Ensure brevity in your answer.  1.05. What is the ratio of the Exports in Kyrgyz Republic in 1997 to that in 1999?
Offer a very short reply. 1.22. What is the ratio of the Exports in Rwanda in 1997 to that in 1999?
Your answer should be very brief. 0.83. What is the ratio of the Exports in Sierra Leone in 1997 to that in 1999?
Give a very brief answer. 1.19. What is the ratio of the Exports in Kyrgyz Republic in 1997 to that in 2000?
Offer a terse response. 1.11. What is the ratio of the Exports of Rwanda in 1997 to that in 2000?
Offer a terse response. 0.82. What is the ratio of the Exports in Sierra Leone in 1997 to that in 2000?
Provide a short and direct response. 0.98. What is the ratio of the Exports in Singapore in 1997 to that in 2000?
Give a very brief answer. 0.85. What is the ratio of the Exports of Kyrgyz Republic in 1997 to that in 2001?
Offer a terse response. 1.14. What is the ratio of the Exports of Rwanda in 1997 to that in 2001?
Your answer should be compact. 0.58. What is the ratio of the Exports of Sierra Leone in 1997 to that in 2001?
Keep it short and to the point. 0.88. What is the ratio of the Exports in Singapore in 1997 to that in 2001?
Give a very brief answer. 0.88. What is the ratio of the Exports in Kyrgyz Republic in 1997 to that in 2002?
Make the answer very short. 1.06. What is the ratio of the Exports of Rwanda in 1997 to that in 2002?
Provide a succinct answer. 0.56. What is the ratio of the Exports of Sierra Leone in 1997 to that in 2002?
Keep it short and to the point. 0.65. What is the ratio of the Exports in Singapore in 1997 to that in 2002?
Your response must be concise. 0.82. What is the ratio of the Exports in Rwanda in 1997 to that in 2003?
Your answer should be very brief. 0.48. What is the ratio of the Exports of Sierra Leone in 1997 to that in 2003?
Ensure brevity in your answer.  0.4. What is the ratio of the Exports of Singapore in 1997 to that in 2003?
Your answer should be compact. 0.72. What is the ratio of the Exports of Kyrgyz Republic in 1998 to that in 1999?
Ensure brevity in your answer.  1.12. What is the ratio of the Exports in Rwanda in 1998 to that in 1999?
Ensure brevity in your answer.  0.84. What is the ratio of the Exports of Singapore in 1998 to that in 1999?
Provide a succinct answer. 0.93. What is the ratio of the Exports in Kyrgyz Republic in 1998 to that in 2000?
Keep it short and to the point. 1.01. What is the ratio of the Exports of Rwanda in 1998 to that in 2000?
Provide a short and direct response. 0.83. What is the ratio of the Exports of Sierra Leone in 1998 to that in 2000?
Ensure brevity in your answer.  0.83. What is the ratio of the Exports in Singapore in 1998 to that in 2000?
Give a very brief answer. 0.81. What is the ratio of the Exports in Kyrgyz Republic in 1998 to that in 2001?
Your answer should be compact. 1.04. What is the ratio of the Exports of Rwanda in 1998 to that in 2001?
Offer a terse response. 0.59. What is the ratio of the Exports in Sierra Leone in 1998 to that in 2001?
Provide a succinct answer. 0.75. What is the ratio of the Exports in Singapore in 1998 to that in 2001?
Make the answer very short. 0.84. What is the ratio of the Exports in Kyrgyz Republic in 1998 to that in 2002?
Your response must be concise. 0.97. What is the ratio of the Exports of Rwanda in 1998 to that in 2002?
Offer a very short reply. 0.57. What is the ratio of the Exports in Sierra Leone in 1998 to that in 2002?
Give a very brief answer. 0.55. What is the ratio of the Exports of Singapore in 1998 to that in 2002?
Provide a short and direct response. 0.78. What is the ratio of the Exports in Kyrgyz Republic in 1998 to that in 2003?
Offer a terse response. 0.92. What is the ratio of the Exports of Rwanda in 1998 to that in 2003?
Give a very brief answer. 0.49. What is the ratio of the Exports in Sierra Leone in 1998 to that in 2003?
Keep it short and to the point. 0.34. What is the ratio of the Exports in Singapore in 1998 to that in 2003?
Keep it short and to the point. 0.68. What is the ratio of the Exports of Kyrgyz Republic in 1999 to that in 2000?
Keep it short and to the point. 0.9. What is the ratio of the Exports of Rwanda in 1999 to that in 2000?
Your answer should be very brief. 0.99. What is the ratio of the Exports in Sierra Leone in 1999 to that in 2000?
Ensure brevity in your answer.  0.82. What is the ratio of the Exports in Singapore in 1999 to that in 2000?
Offer a very short reply. 0.87. What is the ratio of the Exports in Kyrgyz Republic in 1999 to that in 2001?
Make the answer very short. 0.94. What is the ratio of the Exports of Rwanda in 1999 to that in 2001?
Make the answer very short. 0.71. What is the ratio of the Exports of Sierra Leone in 1999 to that in 2001?
Provide a short and direct response. 0.74. What is the ratio of the Exports of Singapore in 1999 to that in 2001?
Provide a short and direct response. 0.91. What is the ratio of the Exports in Kyrgyz Republic in 1999 to that in 2002?
Keep it short and to the point. 0.87. What is the ratio of the Exports in Rwanda in 1999 to that in 2002?
Give a very brief answer. 0.68. What is the ratio of the Exports of Sierra Leone in 1999 to that in 2002?
Your response must be concise. 0.54. What is the ratio of the Exports in Singapore in 1999 to that in 2002?
Keep it short and to the point. 0.84. What is the ratio of the Exports of Kyrgyz Republic in 1999 to that in 2003?
Your answer should be very brief. 0.82. What is the ratio of the Exports in Rwanda in 1999 to that in 2003?
Your answer should be very brief. 0.58. What is the ratio of the Exports in Sierra Leone in 1999 to that in 2003?
Your answer should be compact. 0.34. What is the ratio of the Exports of Singapore in 1999 to that in 2003?
Offer a terse response. 0.74. What is the ratio of the Exports in Kyrgyz Republic in 2000 to that in 2001?
Your answer should be compact. 1.03. What is the ratio of the Exports in Rwanda in 2000 to that in 2001?
Your answer should be compact. 0.71. What is the ratio of the Exports in Sierra Leone in 2000 to that in 2001?
Your response must be concise. 0.89. What is the ratio of the Exports of Singapore in 2000 to that in 2001?
Offer a very short reply. 1.04. What is the ratio of the Exports of Kyrgyz Republic in 2000 to that in 2002?
Your response must be concise. 0.96. What is the ratio of the Exports in Rwanda in 2000 to that in 2002?
Offer a very short reply. 0.68. What is the ratio of the Exports of Sierra Leone in 2000 to that in 2002?
Make the answer very short. 0.66. What is the ratio of the Exports of Singapore in 2000 to that in 2002?
Provide a short and direct response. 0.96. What is the ratio of the Exports of Kyrgyz Republic in 2000 to that in 2003?
Provide a succinct answer. 0.91. What is the ratio of the Exports in Rwanda in 2000 to that in 2003?
Provide a succinct answer. 0.59. What is the ratio of the Exports of Sierra Leone in 2000 to that in 2003?
Your answer should be compact. 0.41. What is the ratio of the Exports in Singapore in 2000 to that in 2003?
Your answer should be compact. 0.84. What is the ratio of the Exports in Kyrgyz Republic in 2001 to that in 2002?
Provide a succinct answer. 0.93. What is the ratio of the Exports of Rwanda in 2001 to that in 2002?
Ensure brevity in your answer.  0.96. What is the ratio of the Exports in Sierra Leone in 2001 to that in 2002?
Your answer should be compact. 0.74. What is the ratio of the Exports in Singapore in 2001 to that in 2002?
Give a very brief answer. 0.93. What is the ratio of the Exports of Kyrgyz Republic in 2001 to that in 2003?
Make the answer very short. 0.88. What is the ratio of the Exports in Rwanda in 2001 to that in 2003?
Your answer should be very brief. 0.83. What is the ratio of the Exports in Sierra Leone in 2001 to that in 2003?
Offer a very short reply. 0.46. What is the ratio of the Exports in Singapore in 2001 to that in 2003?
Keep it short and to the point. 0.81. What is the ratio of the Exports in Kyrgyz Republic in 2002 to that in 2003?
Make the answer very short. 0.95. What is the ratio of the Exports in Rwanda in 2002 to that in 2003?
Keep it short and to the point. 0.86. What is the ratio of the Exports of Sierra Leone in 2002 to that in 2003?
Give a very brief answer. 0.62. What is the ratio of the Exports of Singapore in 2002 to that in 2003?
Your answer should be very brief. 0.88. What is the difference between the highest and the second highest Exports in Kyrgyz Republic?
Offer a very short reply. 3.05e+07. What is the difference between the highest and the second highest Exports in Rwanda?
Give a very brief answer. 2.64e+1. What is the difference between the highest and the second highest Exports of Sierra Leone?
Provide a short and direct response. 2.81e+11. What is the difference between the highest and the second highest Exports in Singapore?
Offer a very short reply. 4.35e+1. What is the difference between the highest and the lowest Exports in Kyrgyz Republic?
Ensure brevity in your answer.  1.12e+09. What is the difference between the highest and the lowest Exports in Rwanda?
Your answer should be very brief. 9.93e+1. What is the difference between the highest and the lowest Exports of Sierra Leone?
Provide a short and direct response. 4.90e+11. What is the difference between the highest and the lowest Exports in Singapore?
Make the answer very short. 1.10e+11. 